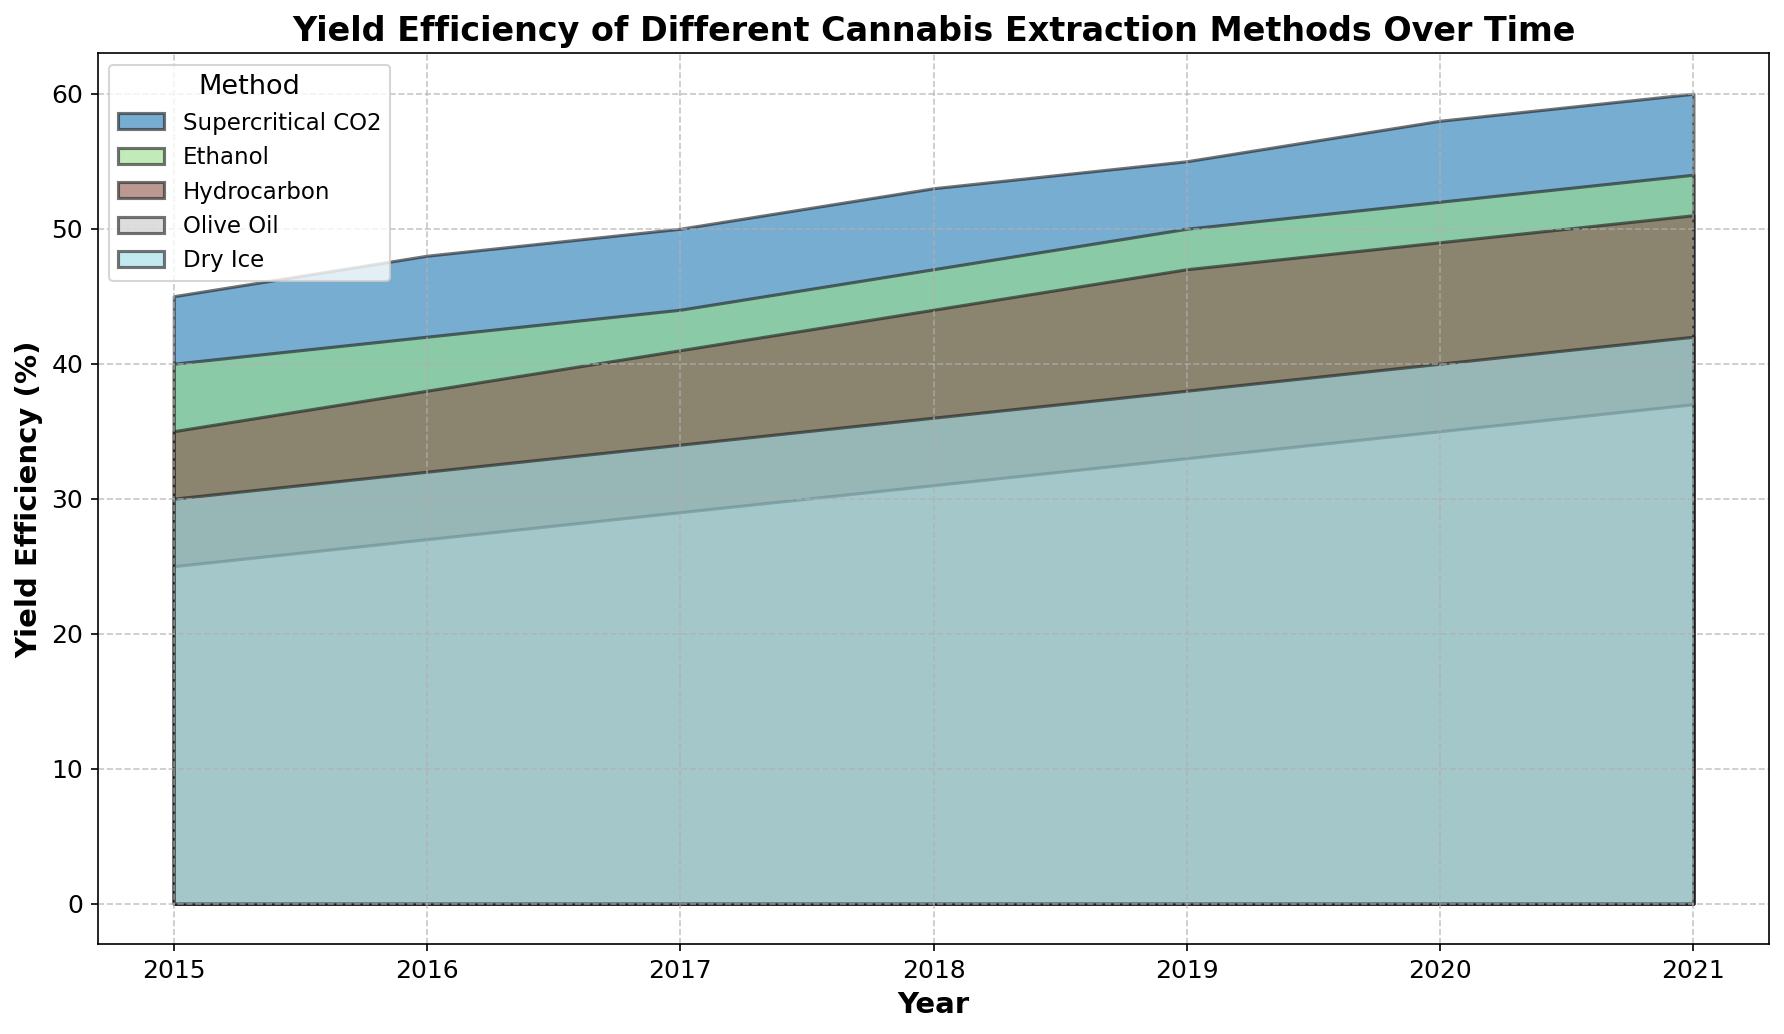What was the increase in yield efficiency for the Supercritical CO2 method from 2015 to 2021? To find the increase, subtract the yield efficiency in 2015 from the yield efficiency in 2021. The yield efficiency in 2021 was 60%, and in 2015, it was 45%. Therefore, the increase is 60% - 45% = 15%.
Answer: 15% Which method showed the least yield efficiency improvement from 2015 to 2021? Compare the improvements for all methods from 2015 to 2021. For Supercritical CO2, the increase is 15% (60%-45%). For Ethanol, it is 14% (54%-40%). For Hydrocarbon, it is 16% (51%-35%). For Olive Oil, it is 12% (37%-25%). For Dry Ice, it is 12% (42%-30%). Both Olive Oil and Dry Ice have the smallest increase which is 12%.
Answer: Olive Oil, Dry Ice What is the difference in yield efficiency between Ethanol and Hydrocarbon methods in 2021? Look at the yield efficiency percentages for Ethanol and Hydrocarbon in 2021. Ethanol has a yield efficiency of 54%, and Hydrocarbon has a yield efficiency of 51%. The difference is 54% - 51% = 3%.
Answer: 3% Which method had the highest yield efficiency in 2018? Compare the yield efficiencies of all methods in 2018. Supercritical CO2 had 53%, Ethanol had 47%, Hydrocarbon had 44%, Olive Oil had 31%, and Dry Ice had 36%. The highest is Supercritical CO2 with 53%.
Answer: Supercritical CO2 What was the trend in the yield efficiency for the Olive Oil method from 2015 to 2021? Observe the yield efficiency values for Olive Oil from 2015 (25%) to 2021 (37%). The values increase each year: 25%, 27%, 29%, 31%, 33%, 35%, 37%. So the trend is gradually increasing.
Answer: Increasing How much did the yield efficiency of the Ethanol method improve between 2017 and 2020? Calculate the difference between the 2017 yield efficiency and the 2020 yield efficiency for Ethanol. In 2017, it was 44%. In 2020, it was 52%. So, the improvement is 52% - 44% = 8%.
Answer: 8% By how much does the yield efficiency of the Supercritical CO2 method exceed that of the Dry Ice method in 2020? Compare the yield efficiencies of Supercritical CO2 and Dry Ice in 2020. Supercritical CO2 is at 58%, and Dry Ice is at 40%. The difference is 58% - 40% = 18%.
Answer: 18% In which year was the yield efficiency of the Hydrocarbon method equal to or greater than 45%? Look for the years where Hydrocarbon's yield efficiency is 45% or more. Starting from 2018 (44%), 2019 (47%), 2020 (49%), and 2021 (51%). The first year it is 45% or more is 2019.
Answer: 2019 Which method has the steepest increase in yield efficiency over the given period? Calculate the difference in yield efficiency from 2015 to 2021 for all methods: Supercritical CO2: 60%-45%=15%, Ethanol: 54%-40%=14%, Hydrocarbon: 51%-35%=16%, Olive Oil: 37%-25%=12%, Dry Ice: 42%-30%=12%. Hydrocarbon has the highest increase of 16%.
Answer: Hydrocarbon 